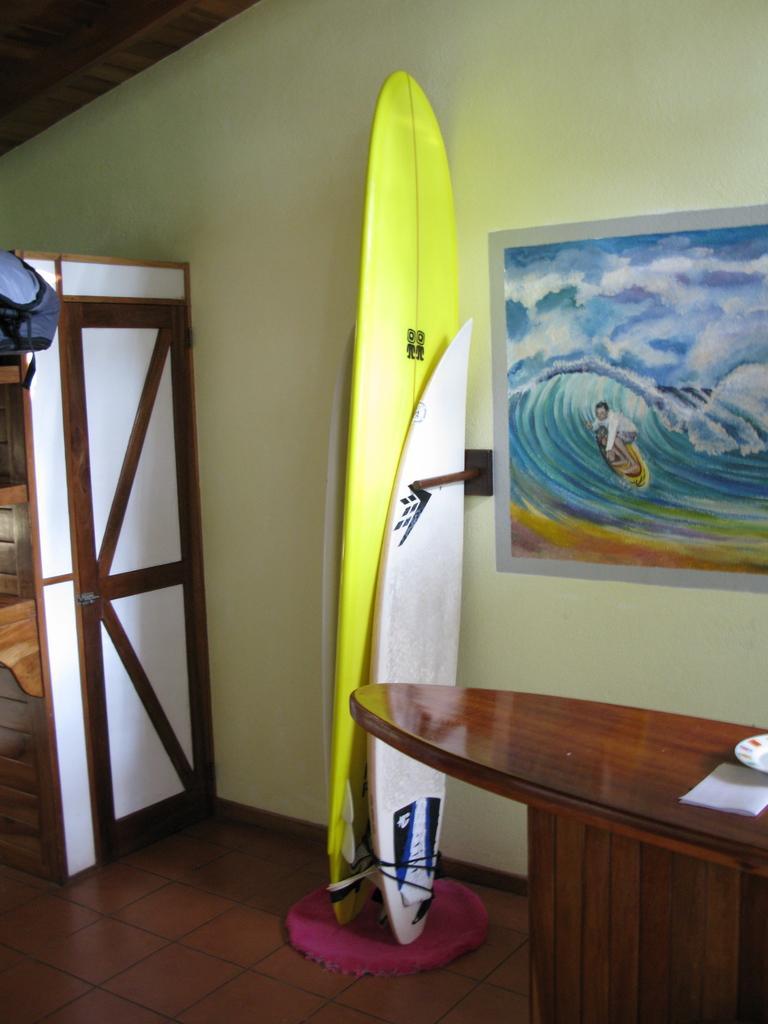Describe this image in one or two sentences. In this image there is a surfboard which is kept near the wall. There is a table in front of the wall. At the background there is a door. There is a painting on the wall. 